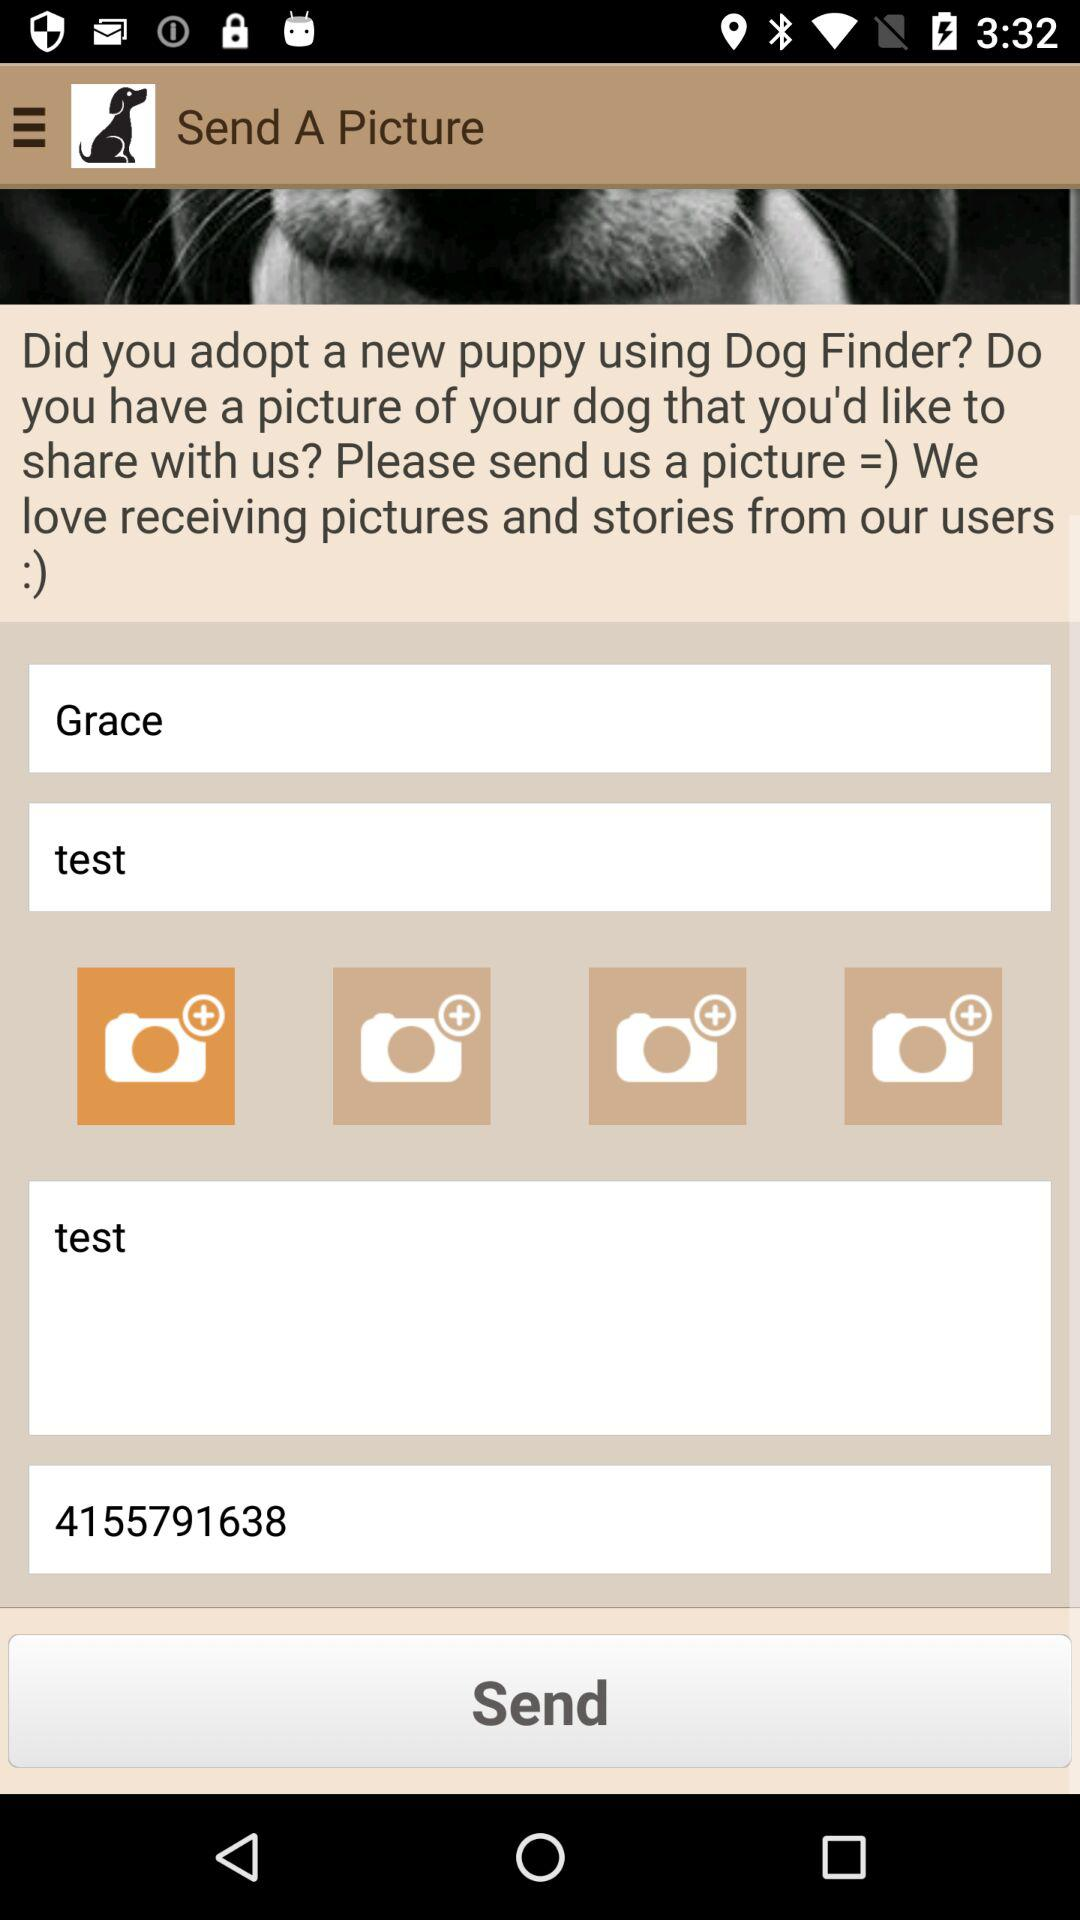What is the entered number? The entered number is 4155791638. 